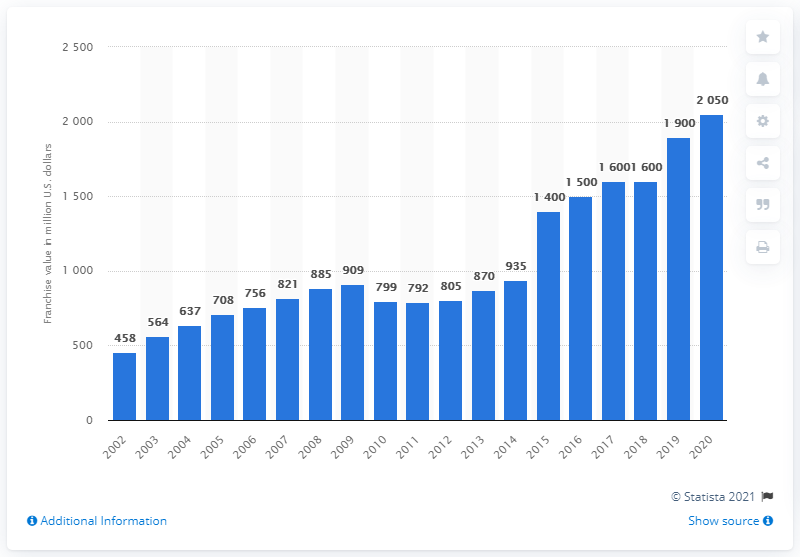Give some essential details in this illustration. The franchise value of the Buffalo Bills in 2020 was approximately 1.475 billion dollars. In 2050, the franchise value is projected to reach approximately 2.625 billion dollars. 